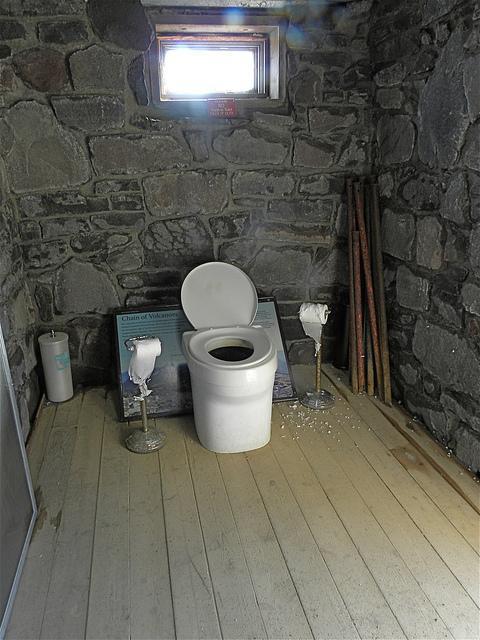How many toilet paper stand in the room?
Give a very brief answer. 2. 